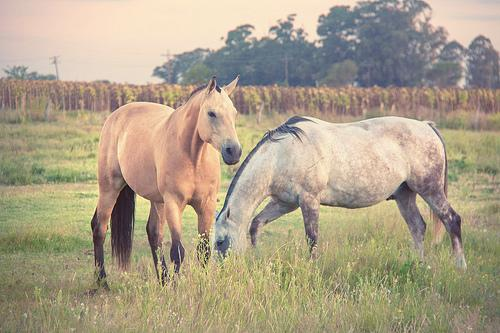Are there any notable features about the horses' appearance? The tan horse has black knees and the white horse has a grey and black mane. Enumerate the two primary subjects of the image. 2. A white and grey-speckled horse with a black mane Mention an object in the background, and describe its appearance. There is a group of tall green, leafy trees in the distance. What are the main colors of the horses in the image? The main colors for the horses are light tan and white with grey specks. Provide a brief summary of the scene in the image. Two horses, one tan and one white, are grazing in a grassy field with tall trees and a cornfield in the background. Describe the surrounding environment where the horses are pictured. The horses are in a grassy field with a cornfield and tall green trees in the distance, and a pink and orange sky overhead. What activity are the animals in the picture engaged in? The horses are grazing in the field. Identify one feature of the atmospheric conditions. The sky has a pink color to it. What type of vegetation is present in the image? Tall grass, a cornfield, and a group of leafy trees. What is the color of the first horse mentioned in the description? The first horse is light tan in color. Mention any expression or action observed in the horse on the left. The horse on the left is staring out in the distance. What is the color of the horses' manes in the image? One horse has a black mane, and the other has a black mane with grey specks. What is special about the tan horse's knees? The tan horse has black knees. Is there a purple horse standing in the background? None of the horses mentioned in the image information have purple color. Write a creatively styled caption for this image. Two majestic horses find solace in a serene meadow, as golden light filters through verdant trees painting the sky pink. Is there a small pond with ducks next to the cornfield? The given information does not make any mention of a pond or any ducks in the image. What color is the grass in the image? green and brown Are there any flying birds in the sky above the horses? There are no mentions of birds, flying or stationary, in the given image information. What color are the weeds with flowers? The weeds have purple flowers. Identify two main colors of the horses present in the image. light tan and grey with black specks Describe the grass in front of the horses. The grass in front of the horses is tall and green. Does the grass in front of the horses have yellow stripes? No, it's not mentioned in the image. What color is the sky in the image? pink What can be observed in the sky in the image? The sky has a pink color to it and also has an orange and dusky area. Choose the correct description of the trees in the image: a) leafy and green b) bare and brown c) snowy and white a) leafy and green Is the tree on the left pink and covered in flowers? There are no mentions of a pink tree or a tree covered in flowers in the given information. Is there a large red house in between the two horses? There's no mention of a house, let alone a large red one, among the objects in the image. Describe the tails of both horses. The tan horse has a long brown tail, and the grey horse has a dark rear flank. Describe the expressions or actions of the two horses in the image. One horse is grazing in the field while the other horse is staring out in the distance. What can be seen in the distance behind the horses? A group of trees and power lines can be seen in the distance. Describe the foliage in the image. The image features green and brown foliage. What type of flowers can be found in the meadow? tiny purple flowers Which horse has a dark nose in the image? The tan horse has a dark nose. Identify the colors of the two horses' heads. The tan horse's head is light tan, whereas the white horse's head is in the grass. Which horse is eating grass? the white horse What grows in the background of the image? corn and green trees 